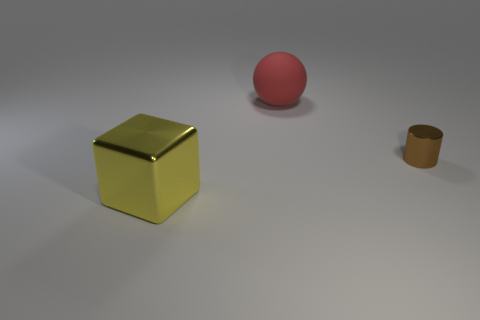Add 2 big cyan metallic things. How many objects exist? 5 Subtract all cylinders. How many objects are left? 2 Subtract 0 gray cylinders. How many objects are left? 3 Subtract all tiny gray rubber cubes. Subtract all small things. How many objects are left? 2 Add 2 big matte balls. How many big matte balls are left? 3 Add 3 blue rubber cylinders. How many blue rubber cylinders exist? 3 